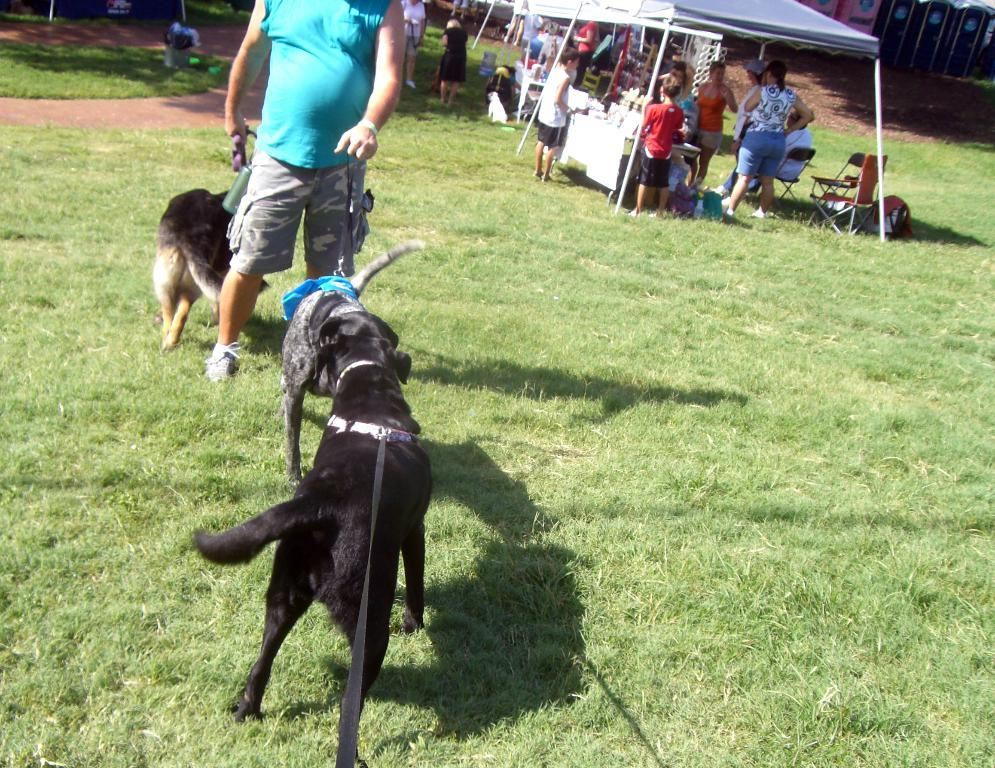What can be seen in the image? There is a group of people and a man standing in the image. Are there any animals present in the image? Yes, there are dogs in the image. What is visible in the background of the image? There are stalls in the background of the image. Can you see any rings on the chickens in the image? There are no chickens present in the image, so it is not possible to see any rings on them. 